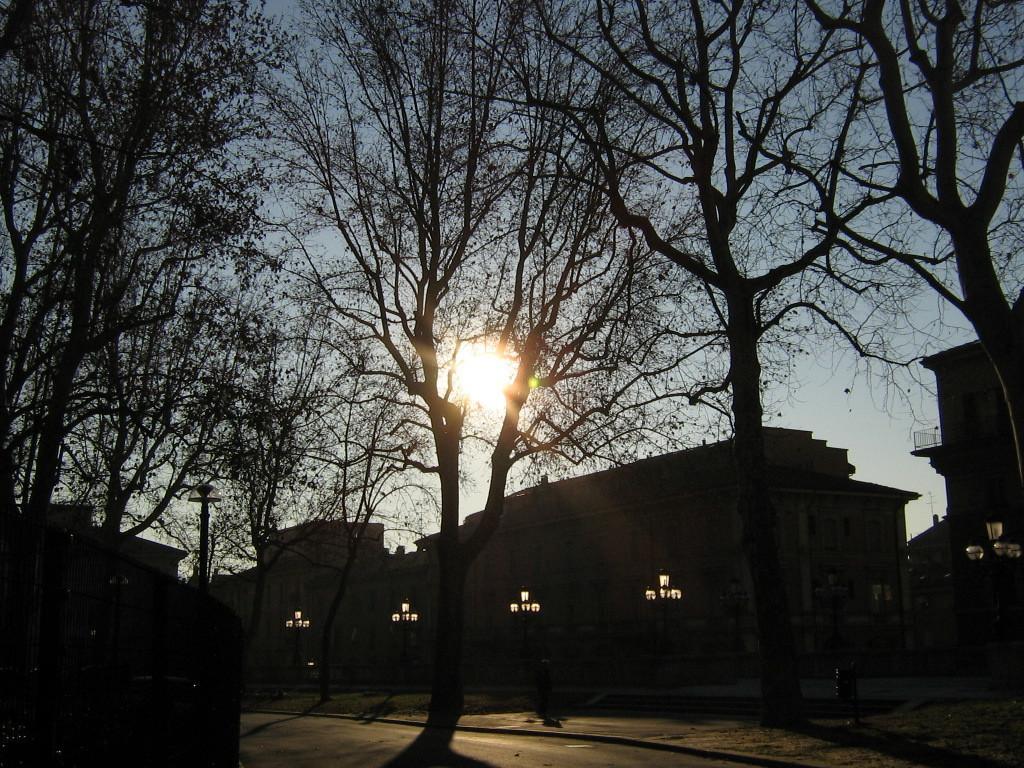Could you give a brief overview of what you see in this image? In this image there are buildings in the background. At the bottom there are trees. At the top there is sun. 